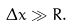Convert formula to latex. <formula><loc_0><loc_0><loc_500><loc_500>\Delta x \gg R .</formula> 